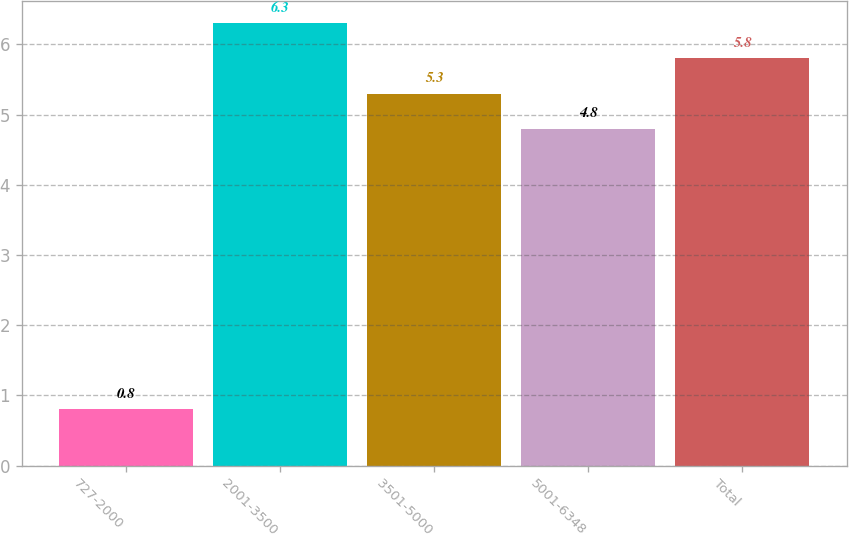Convert chart to OTSL. <chart><loc_0><loc_0><loc_500><loc_500><bar_chart><fcel>727-2000<fcel>2001-3500<fcel>3501-5000<fcel>5001-6348<fcel>Total<nl><fcel>0.8<fcel>6.3<fcel>5.3<fcel>4.8<fcel>5.8<nl></chart> 